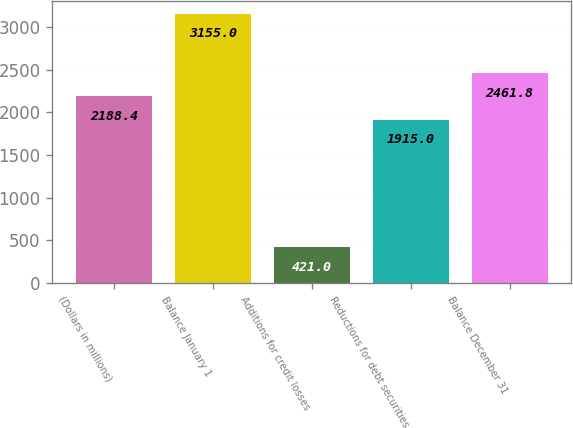<chart> <loc_0><loc_0><loc_500><loc_500><bar_chart><fcel>(Dollars in millions)<fcel>Balance January 1<fcel>Additions for credit losses<fcel>Reductions for debt securities<fcel>Balance December 31<nl><fcel>2188.4<fcel>3155<fcel>421<fcel>1915<fcel>2461.8<nl></chart> 